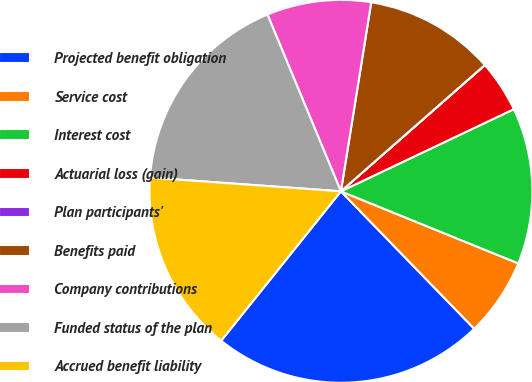Convert chart to OTSL. <chart><loc_0><loc_0><loc_500><loc_500><pie_chart><fcel>Projected benefit obligation<fcel>Service cost<fcel>Interest cost<fcel>Actuarial loss (gain)<fcel>Plan participants'<fcel>Benefits paid<fcel>Company contributions<fcel>Funded status of the plan<fcel>Accrued benefit liability<nl><fcel>23.01%<fcel>6.6%<fcel>13.2%<fcel>4.4%<fcel>0.01%<fcel>11.0%<fcel>8.8%<fcel>17.59%<fcel>15.39%<nl></chart> 